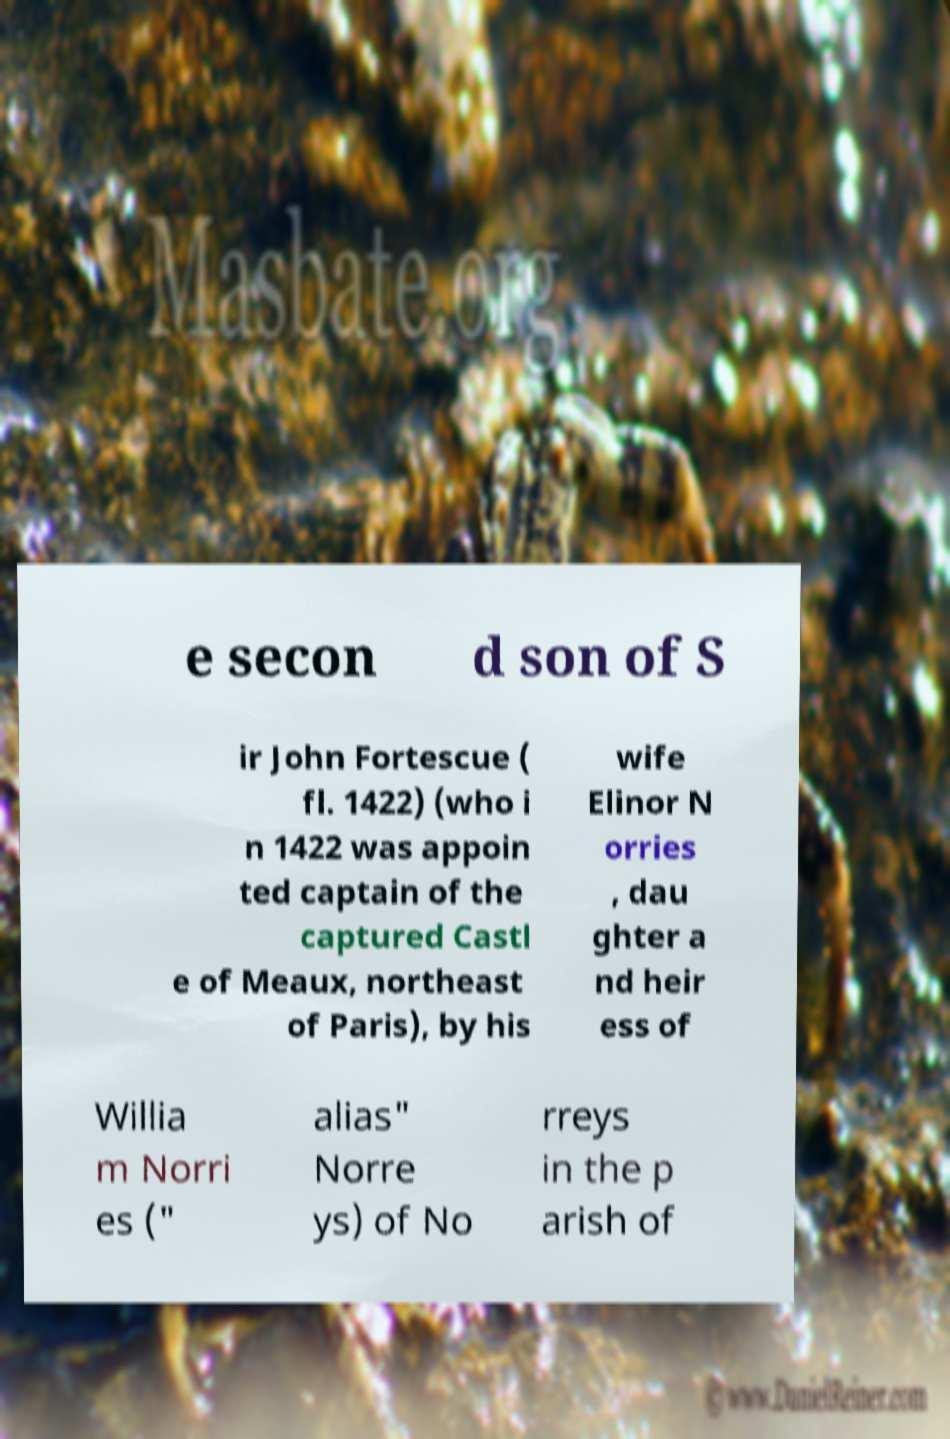I need the written content from this picture converted into text. Can you do that? e secon d son of S ir John Fortescue ( fl. 1422) (who i n 1422 was appoin ted captain of the captured Castl e of Meaux, northeast of Paris), by his wife Elinor N orries , dau ghter a nd heir ess of Willia m Norri es (" alias" Norre ys) of No rreys in the p arish of 